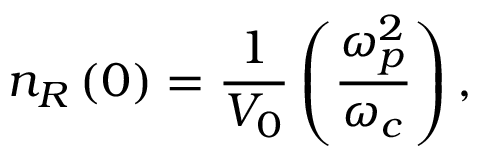<formula> <loc_0><loc_0><loc_500><loc_500>n _ { R } \left ( 0 \right ) = \frac { 1 } { V _ { 0 } } \left ( \frac { \omega _ { p } ^ { 2 } } { \omega _ { c } } \right ) ,</formula> 